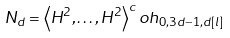<formula> <loc_0><loc_0><loc_500><loc_500>N _ { d } = \left \langle H ^ { 2 } , \dots , H ^ { 2 } \right \rangle ^ { c } o h _ { 0 , 3 d - 1 , d [ l ] }</formula> 